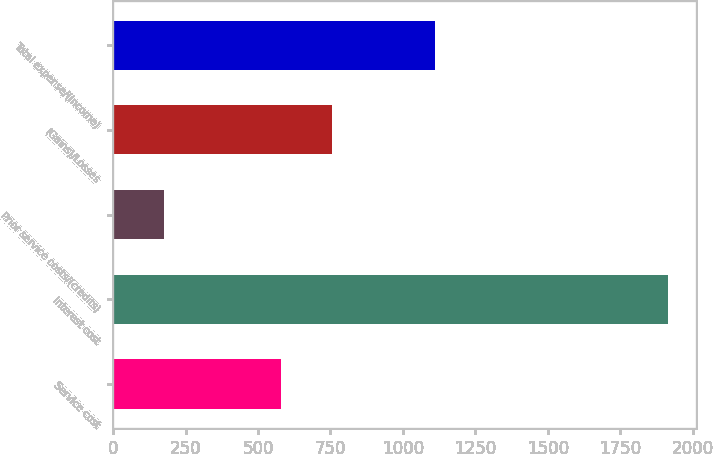Convert chart to OTSL. <chart><loc_0><loc_0><loc_500><loc_500><bar_chart><fcel>Service cost<fcel>Interest cost<fcel>Prior service costs/(credits)<fcel>(Gains)/Losses<fcel>Total expense/(income)<nl><fcel>581<fcel>1914<fcel>174<fcel>755<fcel>1112<nl></chart> 